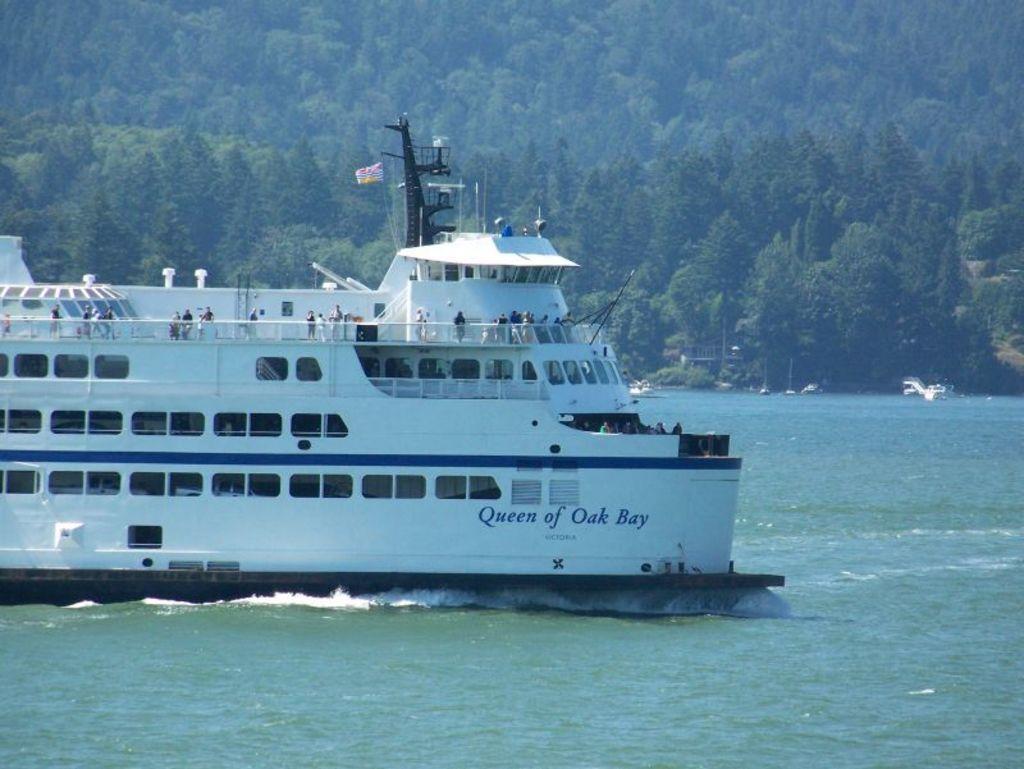Can you describe this image briefly? In this image we can see a ship on the surface of the water. Background of the image so many trees are there. 